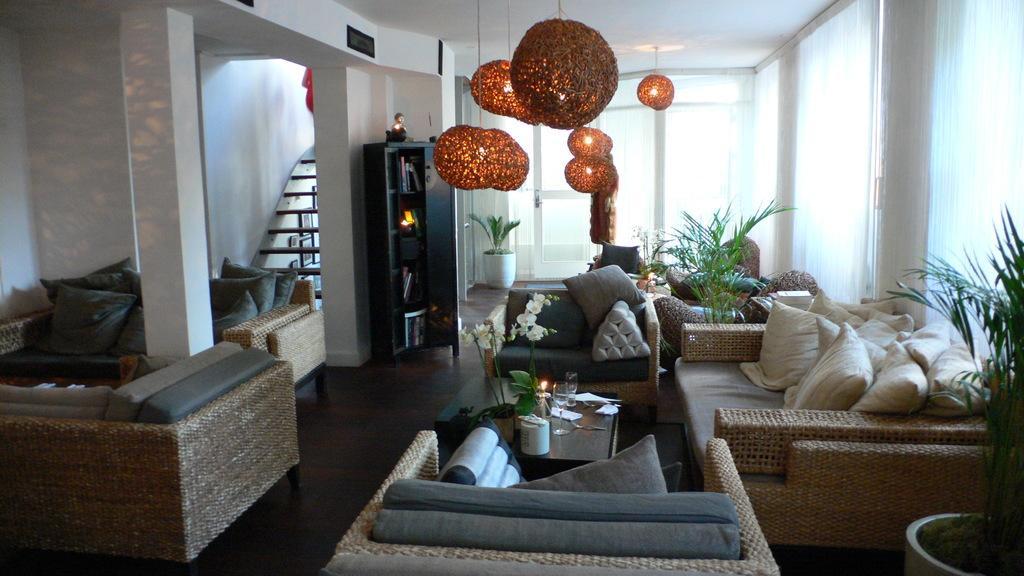Please provide a concise description of this image. In this room we can see pillows on the chairs,sofa and a couch and there are glasses,flower vase,papers and other objects on a table in the middle. In the background we can see staircase,wall,books on the racks,decorative lights are hanging to the ceiling,windows,curtains and house plants. 